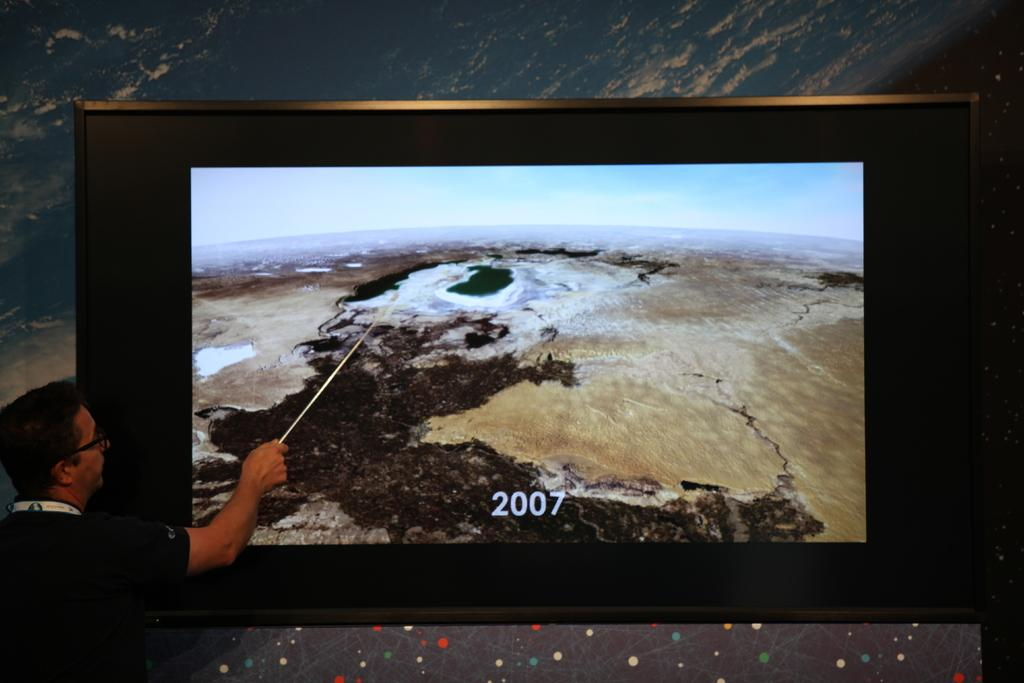Provide a one-sentence caption for the provided image. A man pointing toward a scene on a picture with 2007 on it. 